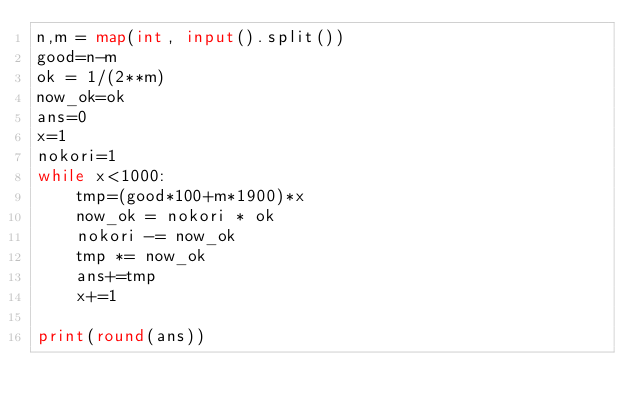Convert code to text. <code><loc_0><loc_0><loc_500><loc_500><_Python_>n,m = map(int, input().split())
good=n-m
ok = 1/(2**m)
now_ok=ok
ans=0
x=1
nokori=1
while x<1000:
    tmp=(good*100+m*1900)*x
    now_ok = nokori * ok
    nokori -= now_ok
    tmp *= now_ok
    ans+=tmp
    x+=1

print(round(ans))</code> 